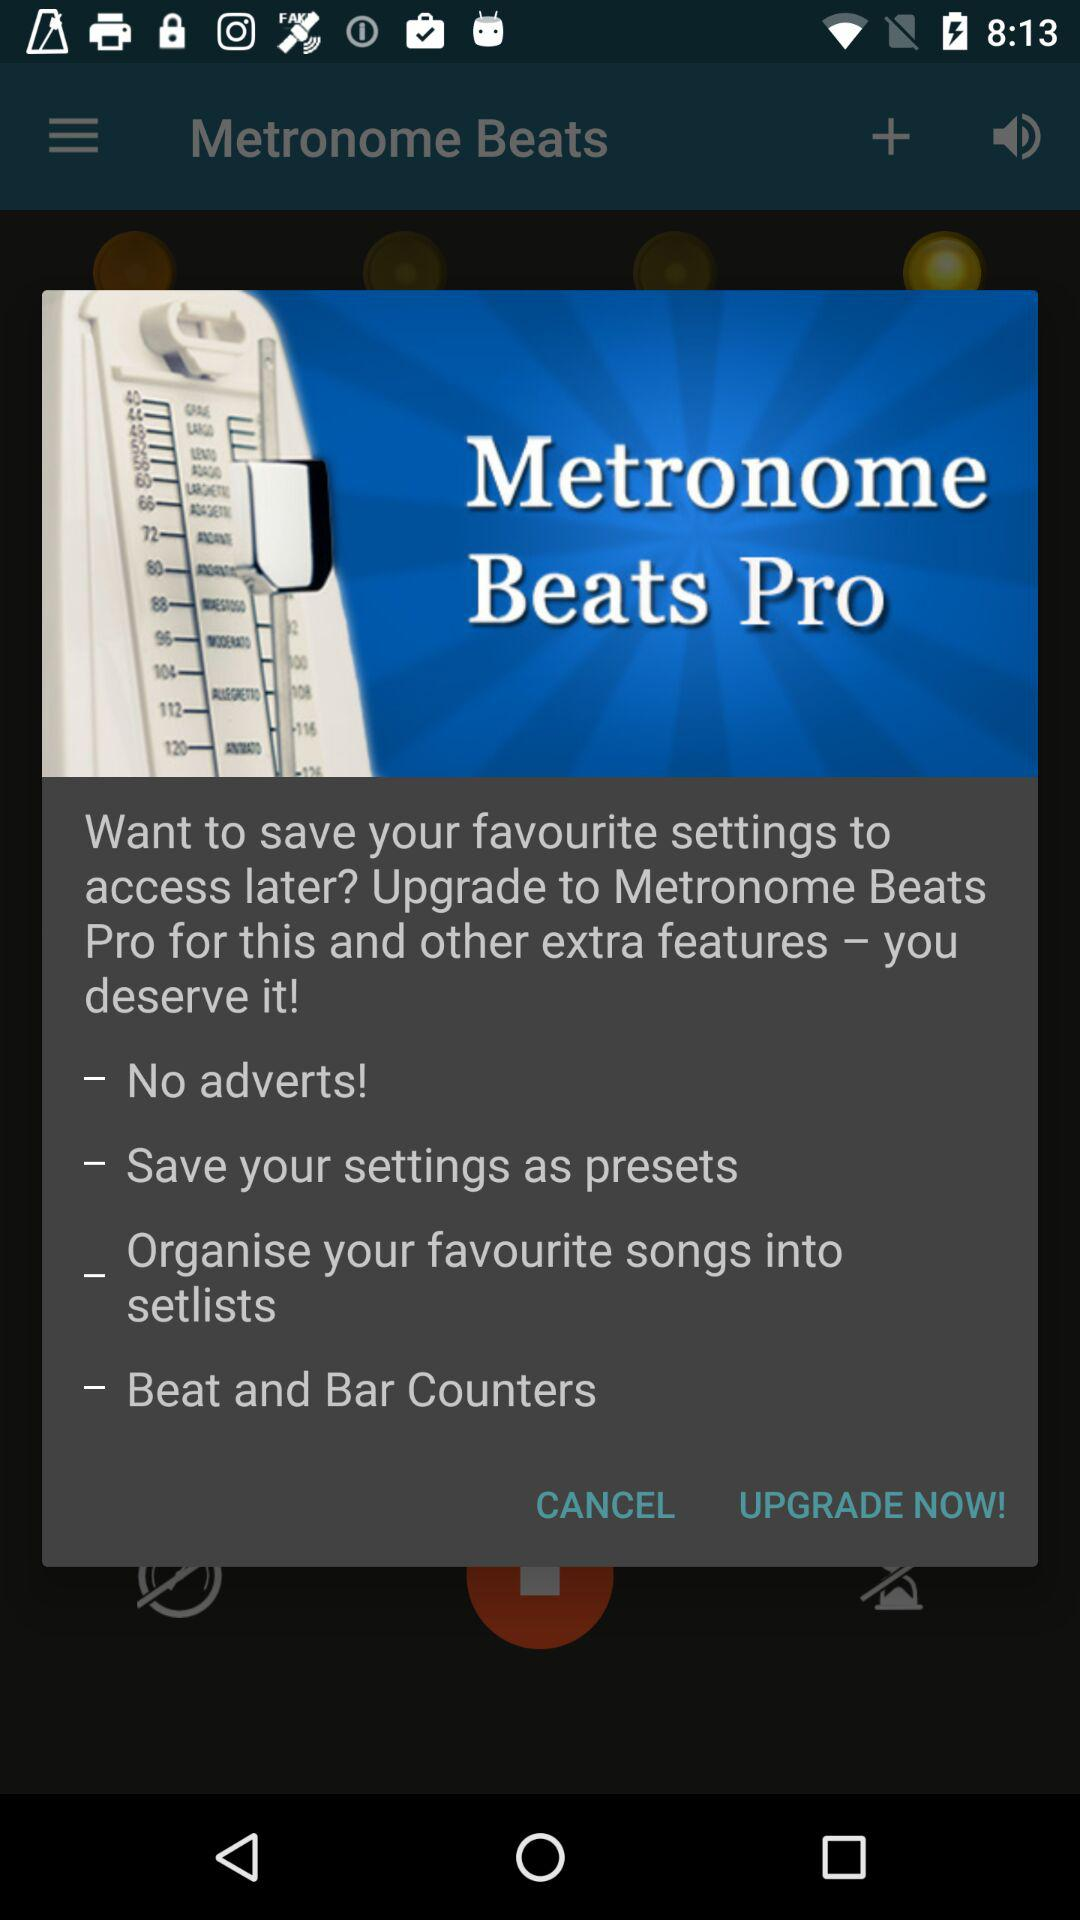What extra features will you get if you subscribe to "Metronome Beats Pro"? If you subscribe to "Metronome Beats Pro", the features you will get are "No adverts!", "Save your settings as presets", "Organise your favourite songs into setlists" and "Beat and Bar Counters". 